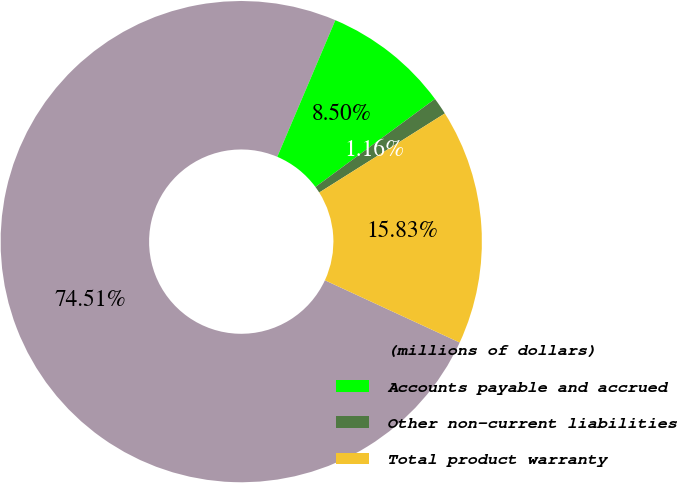<chart> <loc_0><loc_0><loc_500><loc_500><pie_chart><fcel>(millions of dollars)<fcel>Accounts payable and accrued<fcel>Other non-current liabilities<fcel>Total product warranty<nl><fcel>74.51%<fcel>8.5%<fcel>1.16%<fcel>15.83%<nl></chart> 